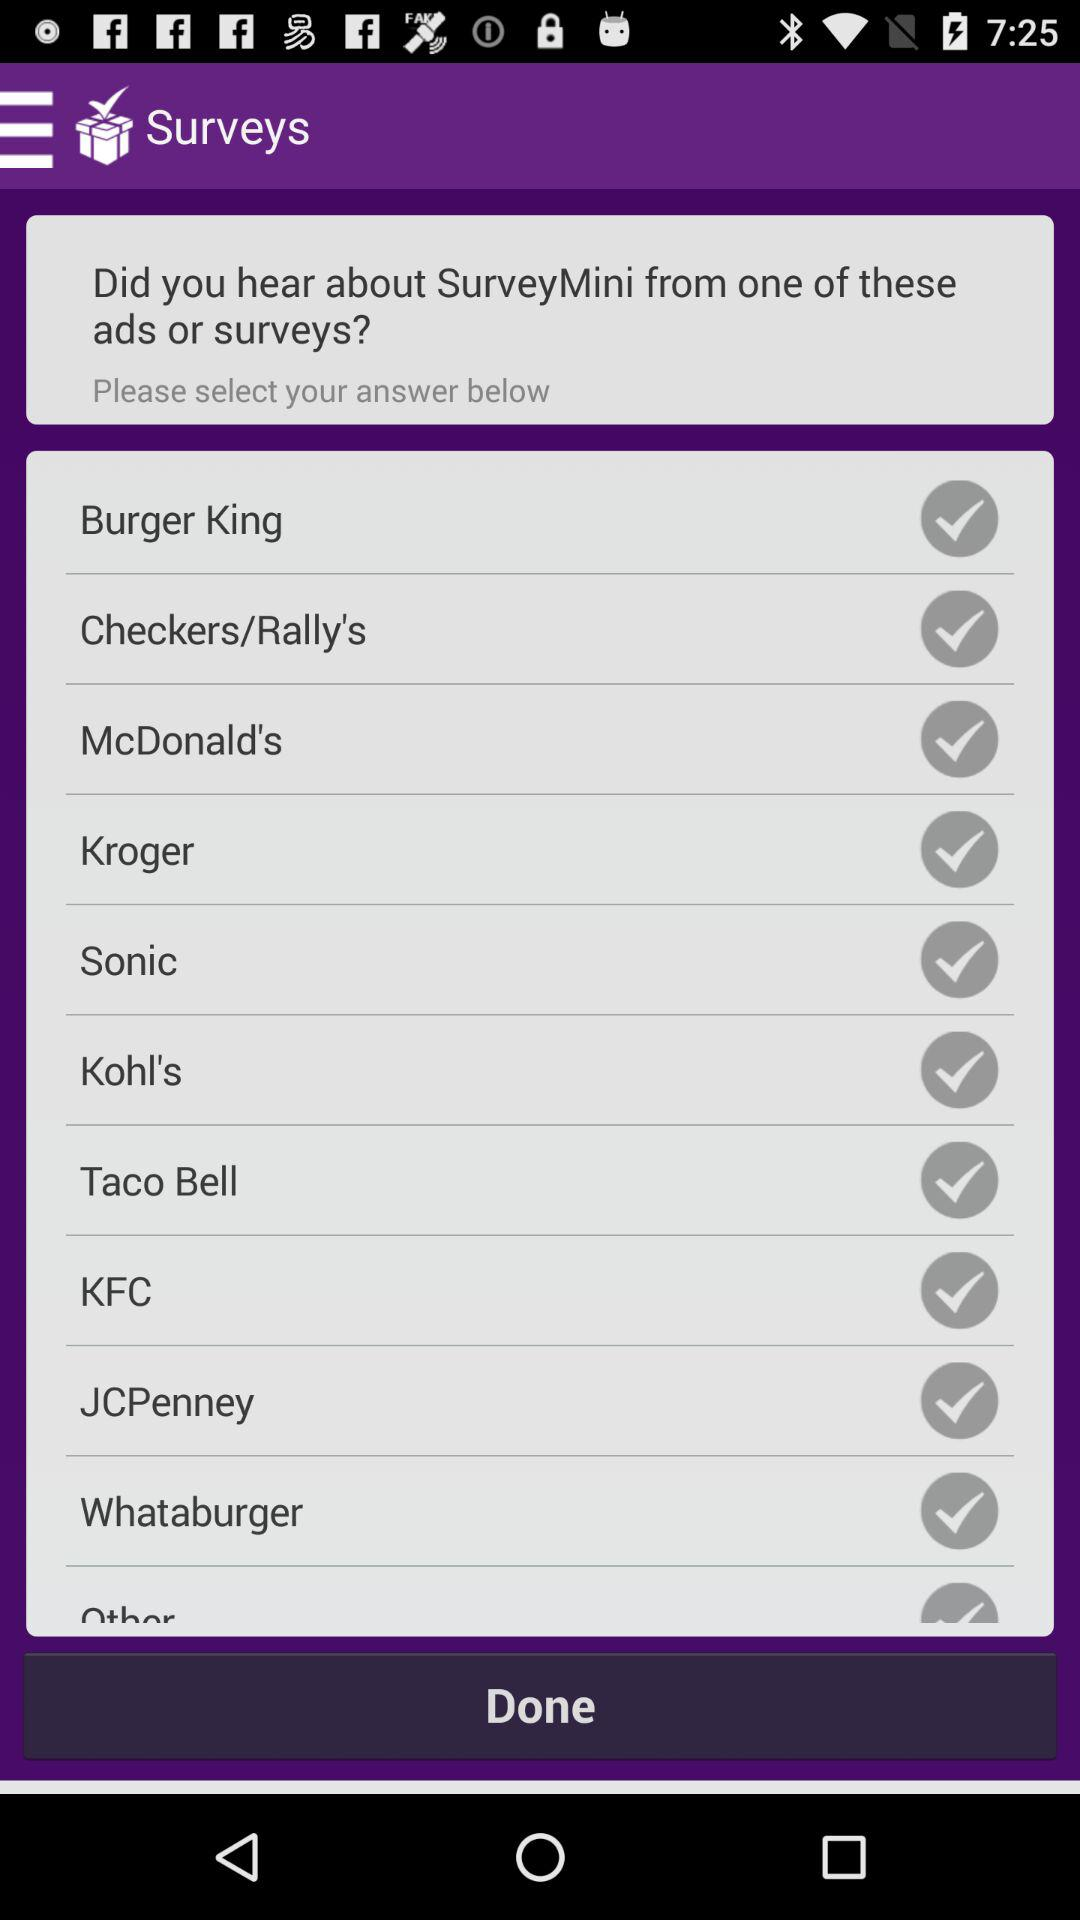What's the status of Burger King? The status is "off". 